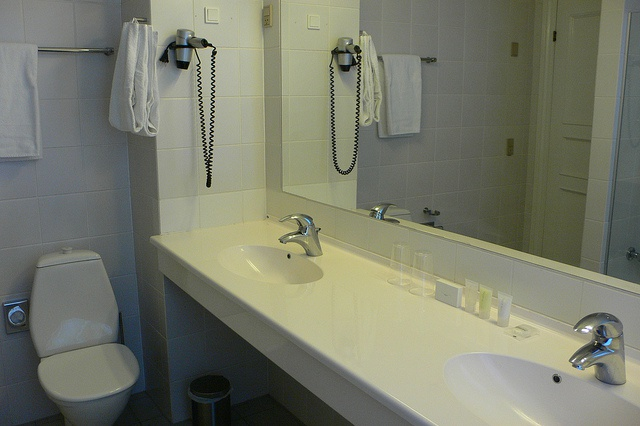Describe the objects in this image and their specific colors. I can see toilet in gray and black tones, sink in gray, darkgray, beige, and lightgray tones, sink in gray, tan, and khaki tones, cup in gray and tan tones, and cup in gray and tan tones in this image. 